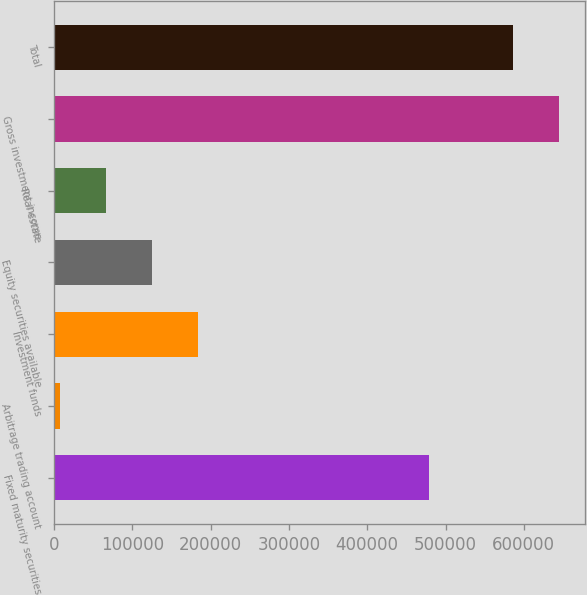<chart> <loc_0><loc_0><loc_500><loc_500><bar_chart><fcel>Fixed maturity securities<fcel>Arbitrage trading account<fcel>Investment funds<fcel>Equity securities available<fcel>Real estate<fcel>Gross investment income<fcel>Total<nl><fcel>479035<fcel>8286<fcel>183656<fcel>125199<fcel>66742.6<fcel>645220<fcel>586763<nl></chart> 